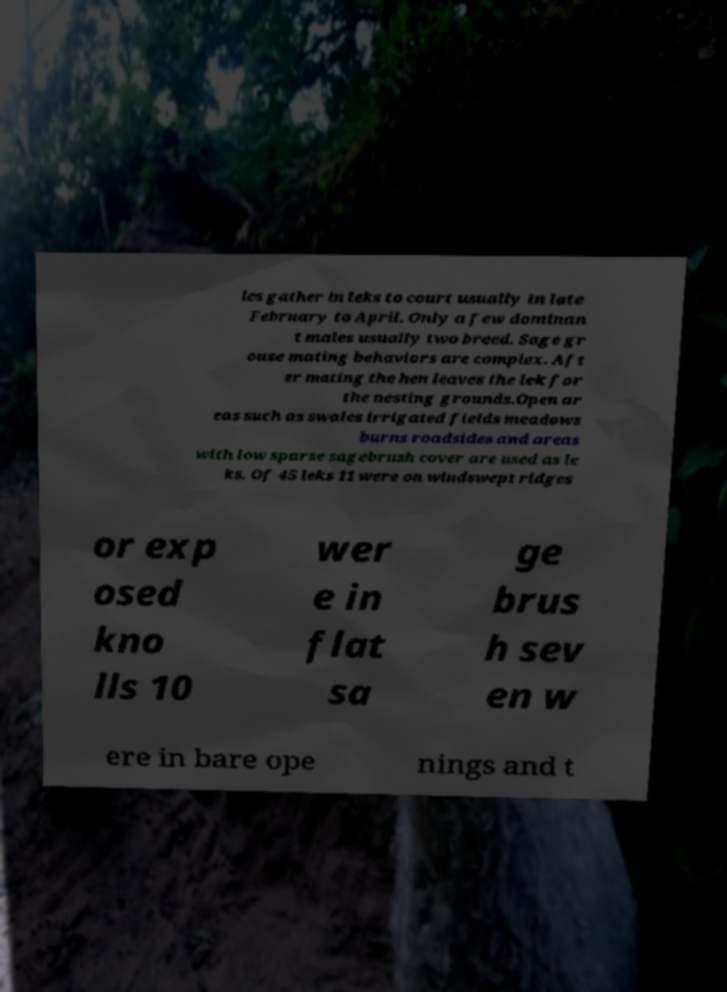Please identify and transcribe the text found in this image. les gather in leks to court usually in late February to April. Only a few dominan t males usually two breed. Sage gr ouse mating behaviors are complex. Aft er mating the hen leaves the lek for the nesting grounds.Open ar eas such as swales irrigated fields meadows burns roadsides and areas with low sparse sagebrush cover are used as le ks. Of 45 leks 11 were on windswept ridges or exp osed kno lls 10 wer e in flat sa ge brus h sev en w ere in bare ope nings and t 